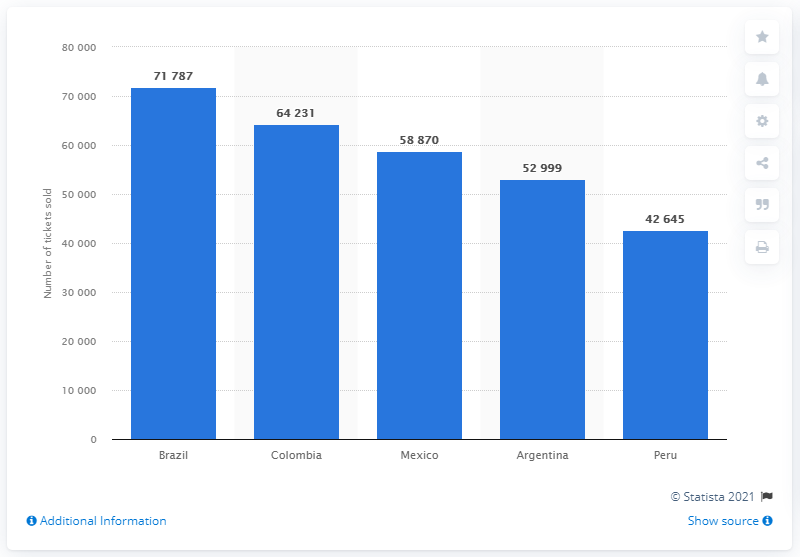Draw attention to some important aspects in this diagram. Brazil was the Latin American country with the highest number of soccer fans purchasing tickets. 